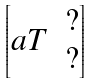Convert formula to latex. <formula><loc_0><loc_0><loc_500><loc_500>\begin{bmatrix} a T & \begin{matrix} ? \\ ? \end{matrix} \end{bmatrix}</formula> 